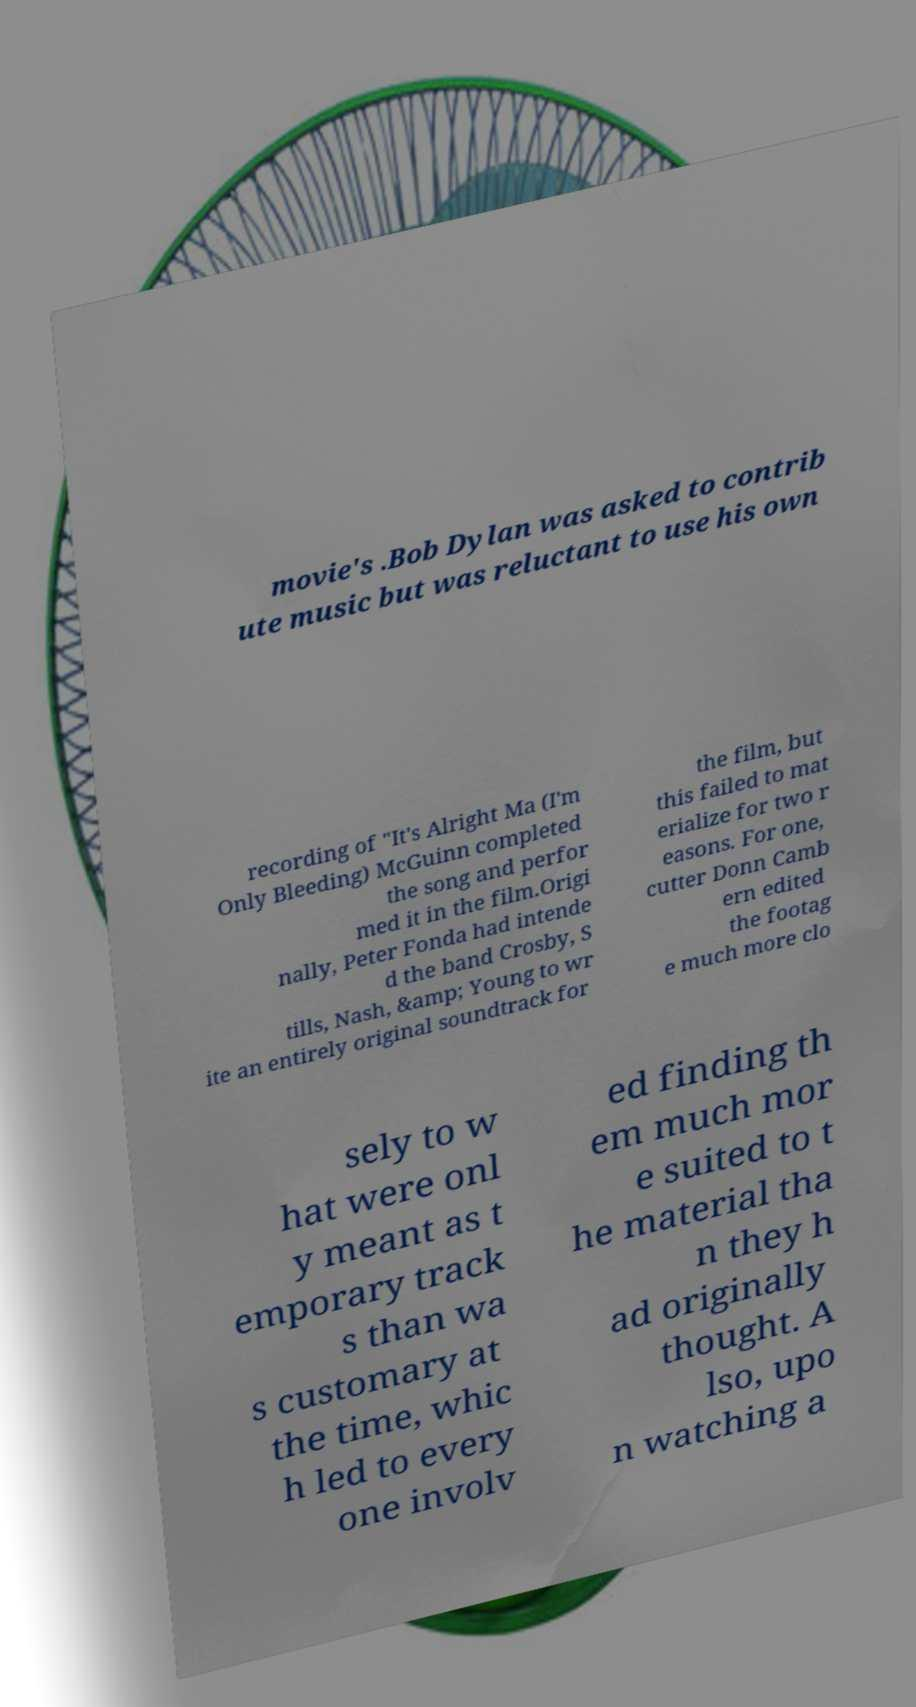Can you read and provide the text displayed in the image?This photo seems to have some interesting text. Can you extract and type it out for me? movie's .Bob Dylan was asked to contrib ute music but was reluctant to use his own recording of "It's Alright Ma (I'm Only Bleeding) McGuinn completed the song and perfor med it in the film.Origi nally, Peter Fonda had intende d the band Crosby, S tills, Nash, &amp; Young to wr ite an entirely original soundtrack for the film, but this failed to mat erialize for two r easons. For one, cutter Donn Camb ern edited the footag e much more clo sely to w hat were onl y meant as t emporary track s than wa s customary at the time, whic h led to every one involv ed finding th em much mor e suited to t he material tha n they h ad originally thought. A lso, upo n watching a 